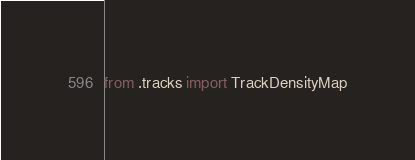<code> <loc_0><loc_0><loc_500><loc_500><_Python_>from .tracks import TrackDensityMap
</code> 